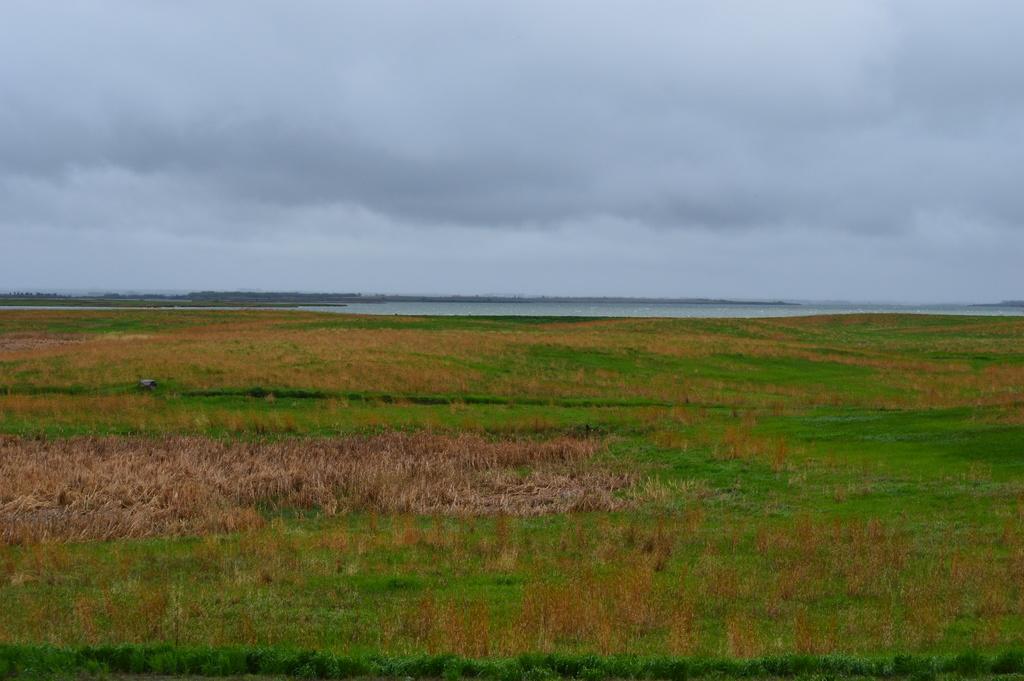Please provide a concise description of this image. In this image I can see around and at the top I can see the sky and the sky is cloudy. 